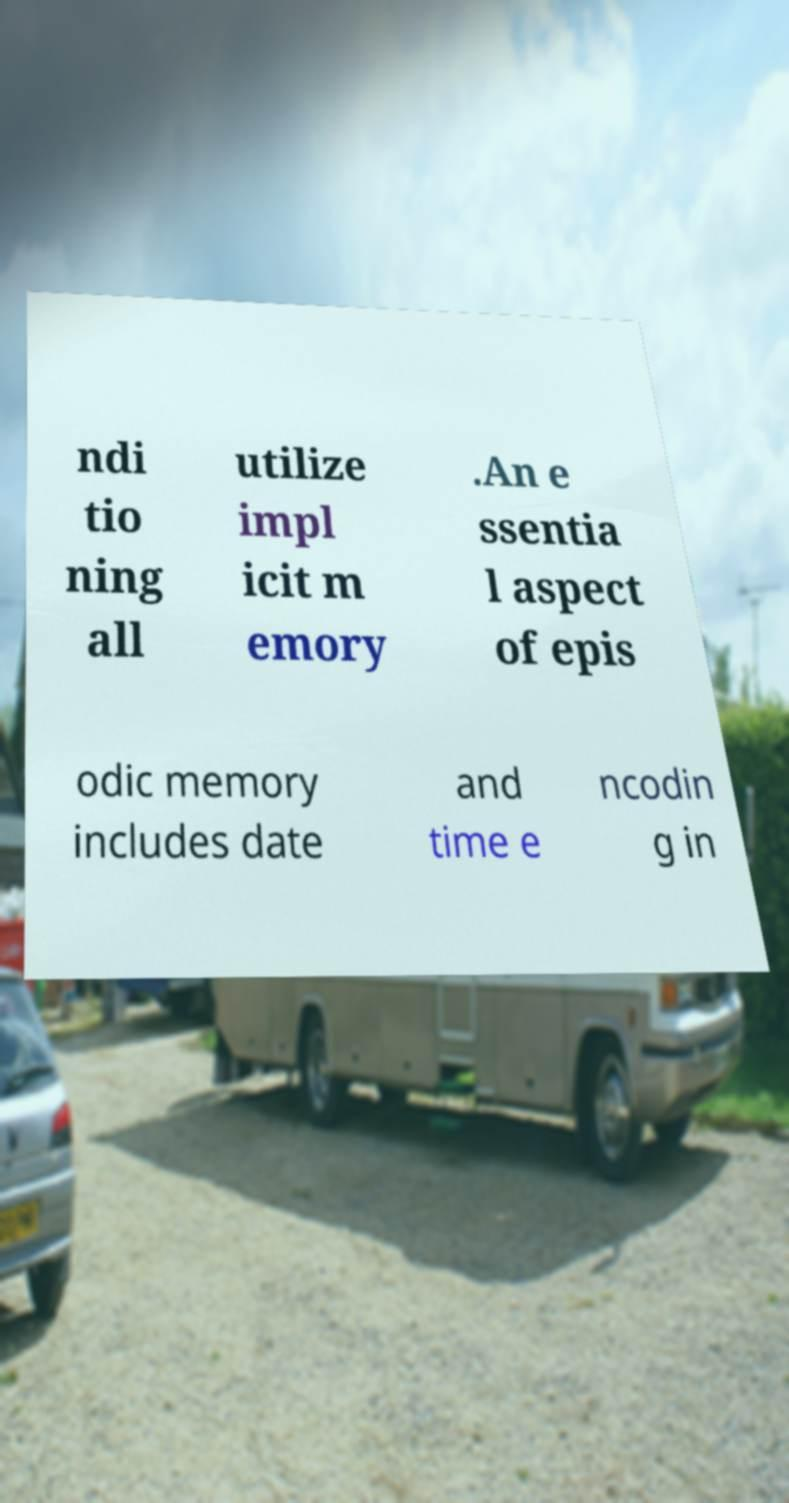Please read and relay the text visible in this image. What does it say? ndi tio ning all utilize impl icit m emory .An e ssentia l aspect of epis odic memory includes date and time e ncodin g in 